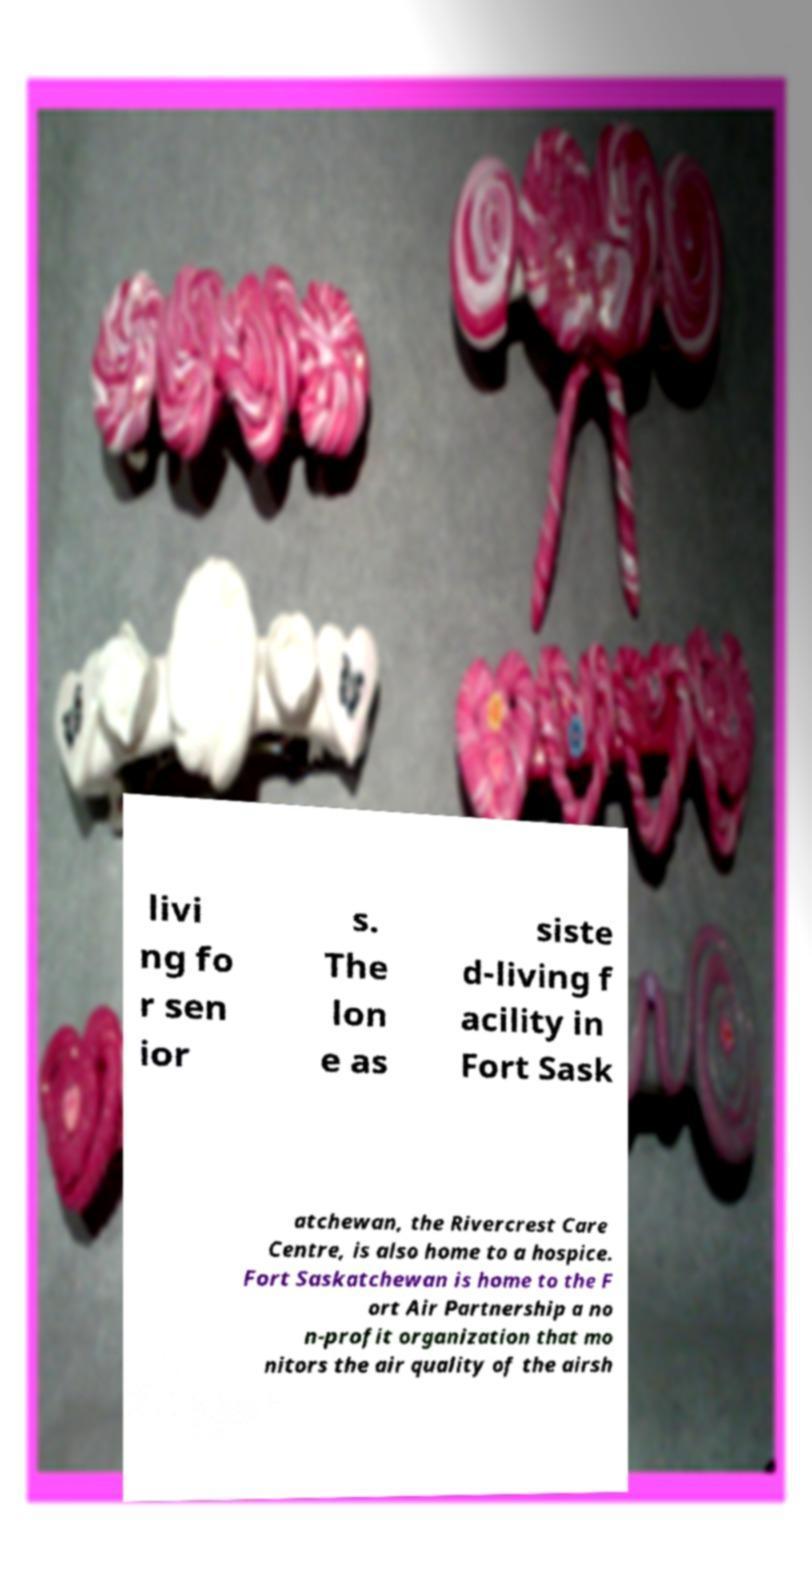I need the written content from this picture converted into text. Can you do that? livi ng fo r sen ior s. The lon e as siste d-living f acility in Fort Sask atchewan, the Rivercrest Care Centre, is also home to a hospice. Fort Saskatchewan is home to the F ort Air Partnership a no n-profit organization that mo nitors the air quality of the airsh 